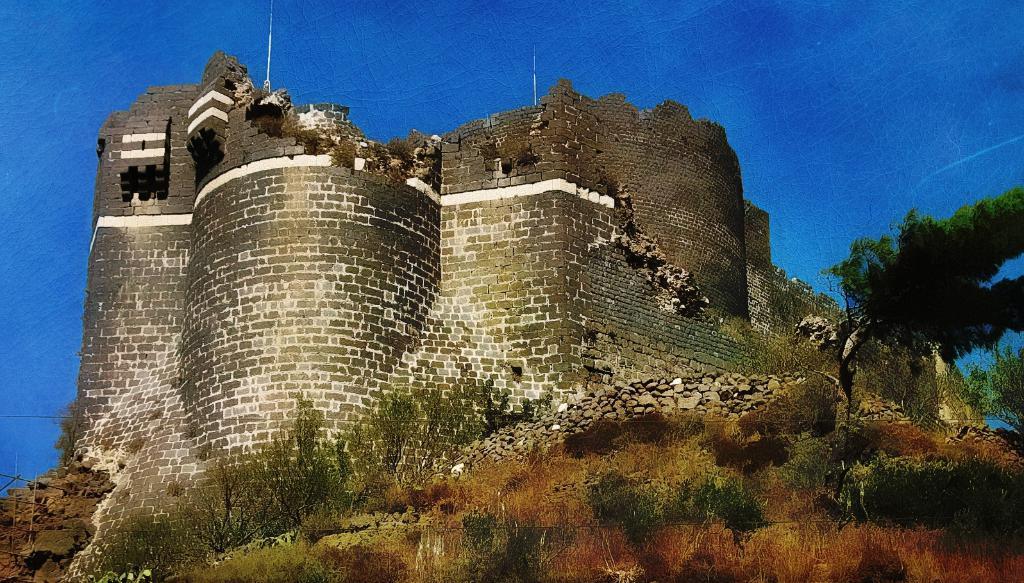Please provide a concise description of this image. In this picture I can observe a monument. There are some plants and stones on the land. On the right side I can observe some trees. In the background there is sky. 